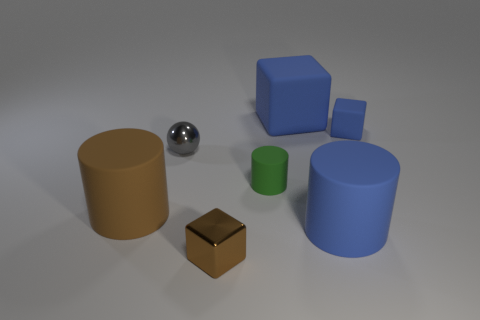What is the shape of the large rubber object that is the same color as the metallic cube?
Ensure brevity in your answer.  Cylinder. Is there a cylinder that has the same color as the small metallic cube?
Keep it short and to the point. Yes. What size is the thing that is the same color as the tiny shiny cube?
Give a very brief answer. Large. Do the large matte block and the tiny matte cube have the same color?
Your answer should be compact. Yes. There is a blue thing to the left of the large blue thing that is in front of the gray ball; what shape is it?
Make the answer very short. Cube. Are there fewer gray things than red balls?
Ensure brevity in your answer.  No. There is a rubber cylinder that is right of the tiny brown metallic object and on the left side of the blue cylinder; how big is it?
Provide a short and direct response. Small. Is the gray shiny object the same size as the brown cube?
Your response must be concise. Yes. There is a small cube that is behind the gray thing; is it the same color as the big block?
Your response must be concise. Yes. There is a big blue cube; what number of tiny matte cylinders are behind it?
Give a very brief answer. 0. 